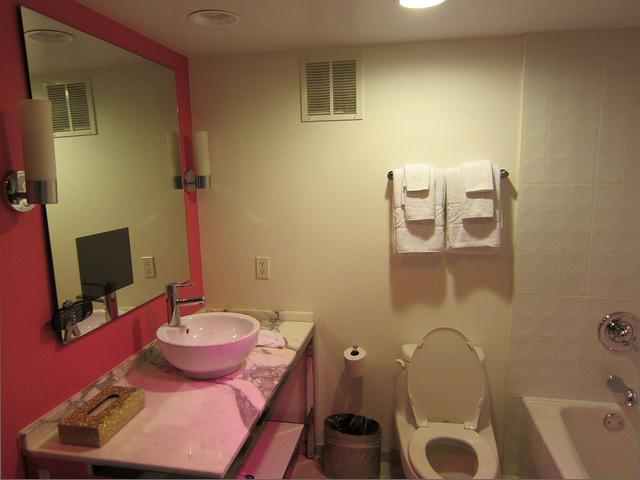What electronic device is embedded within the bathroom mirror in this bathroom?

Choices:
A) phone
B) television
C) heater
D) light television 